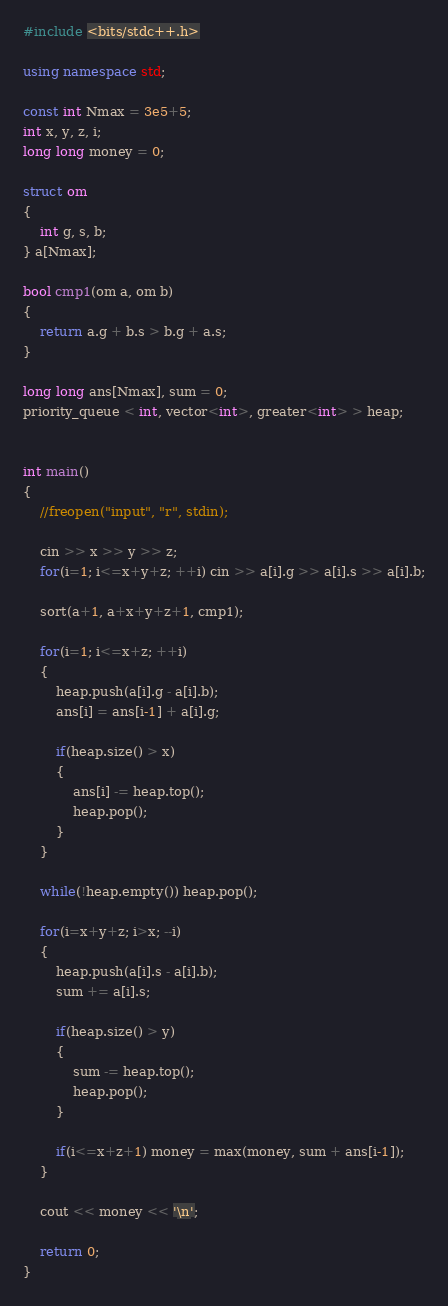Convert code to text. <code><loc_0><loc_0><loc_500><loc_500><_C++_>#include <bits/stdc++.h>

using namespace std;

const int Nmax = 3e5+5;
int x, y, z, i;
long long money = 0;

struct om
{
    int g, s, b;
} a[Nmax];

bool cmp1(om a, om b)
{
    return a.g + b.s > b.g + a.s;
}

long long ans[Nmax], sum = 0;
priority_queue < int, vector<int>, greater<int> > heap;


int main()
{
    //freopen("input", "r", stdin);

    cin >> x >> y >> z;
    for(i=1; i<=x+y+z; ++i) cin >> a[i].g >> a[i].s >> a[i].b;

    sort(a+1, a+x+y+z+1, cmp1);

    for(i=1; i<=x+z; ++i)
    {
        heap.push(a[i].g - a[i].b);
        ans[i] = ans[i-1] + a[i].g;

        if(heap.size() > x)
        {
            ans[i] -= heap.top();
            heap.pop();
        }
    }

    while(!heap.empty()) heap.pop();

    for(i=x+y+z; i>x; --i)
    {
        heap.push(a[i].s - a[i].b);
        sum += a[i].s;

        if(heap.size() > y)
        {
            sum -= heap.top();
            heap.pop();
        }

        if(i<=x+z+1) money = max(money, sum + ans[i-1]);
    }

    cout << money << '\n';

    return 0;
}
</code> 